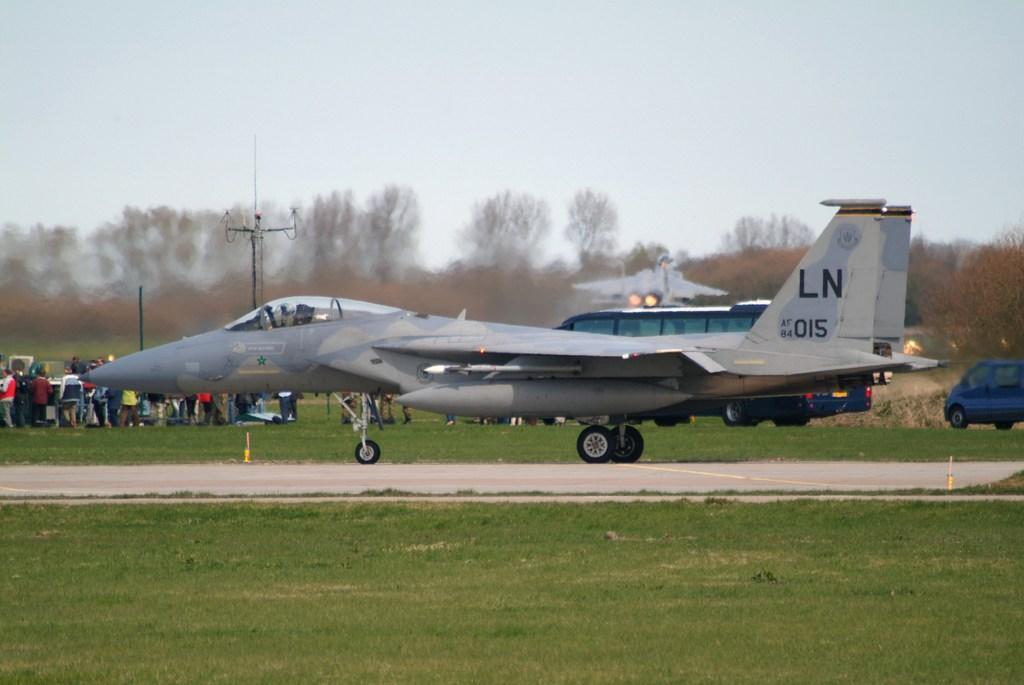<image>
Render a clear and concise summary of the photo. A display from the Air force and one of the aircraft is LN015 